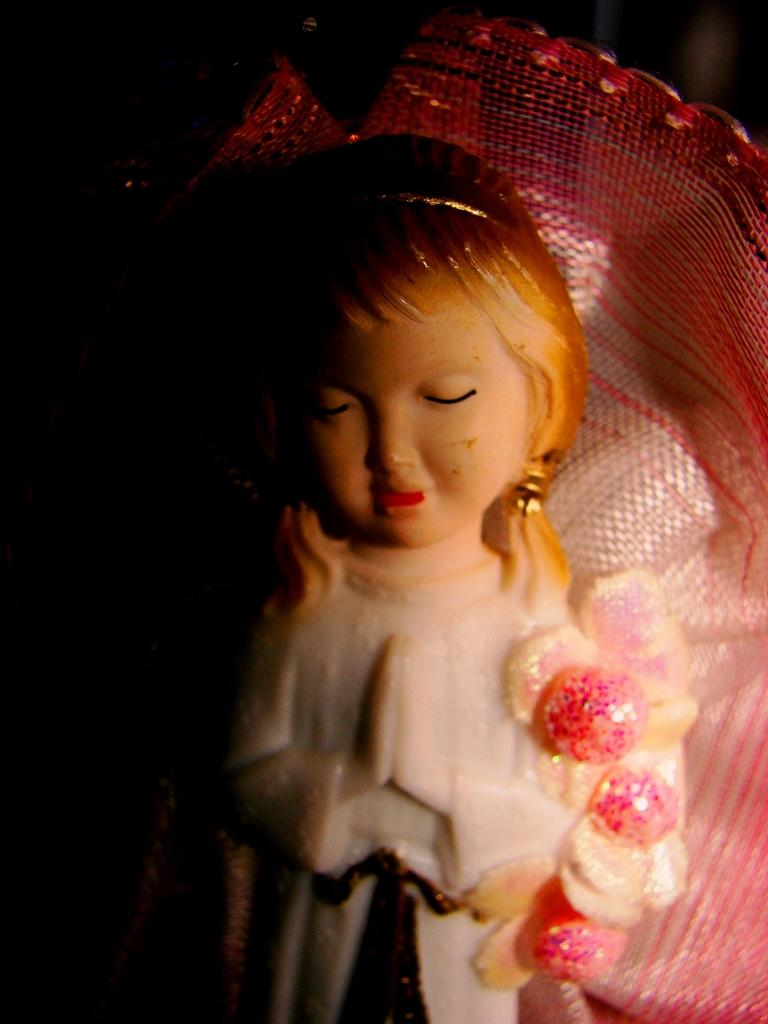What type of object is in the image? There is a toy in the image. Can you describe the appearance of the toy? The toy looks like a porcelain doll. What type of oil is used to lubricate the toy in the image? There is no mention of oil or any lubrication in the image; the toy is a porcelain doll. What type of fiction is the toy based on in the image? The image does not provide any information about the toy being based on any specific fiction. 